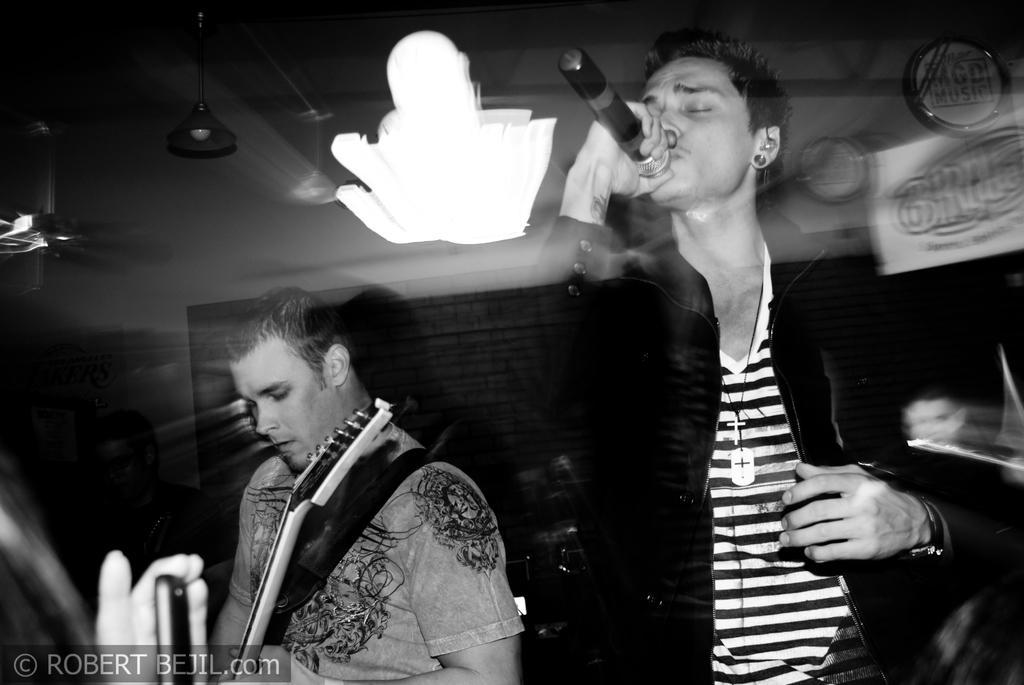Please provide a concise description of this image. There are 2 persons,one is playing guitar and the other is singing. 